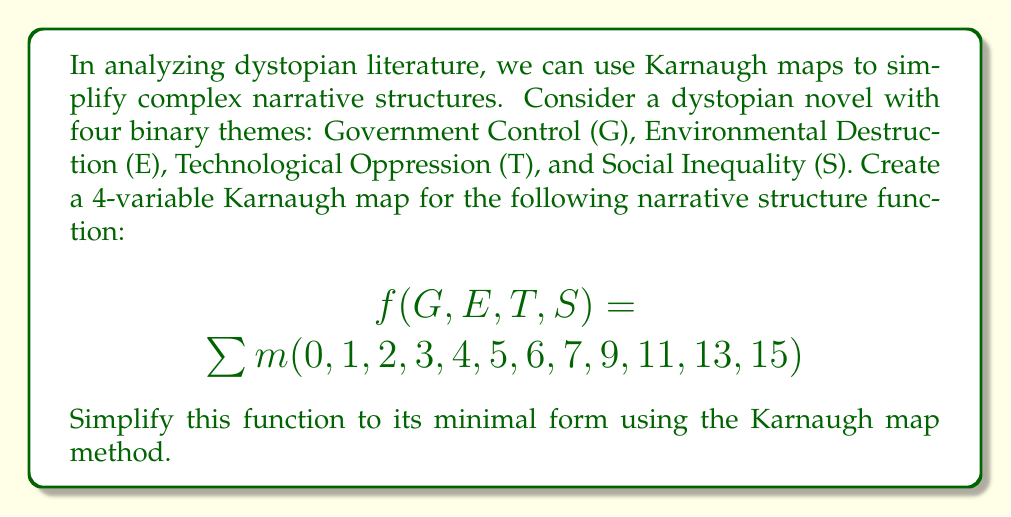Give your solution to this math problem. 1. First, we create a 4-variable Karnaugh map:

[asy]
unitsize(1cm);
for(int i=0; i<4; ++i) {
  for(int j=0; j<4; ++j) {
    draw((i,j)--(i+1,j)--(i+1,j+1)--(i,j+1)--cycle);
  }
}
label("00", (0.5,-0.5));
label("01", (1.5,-0.5));
label("11", (2.5,-0.5));
label("10", (3.5,-0.5));
label("00", (-0.5,0.5));
label("01", (-0.5,1.5));
label("11", (-0.5,2.5));
label("10", (-0.5,3.5));
label("GE", (-0.5,-0.5));
label("TS", (4.5,3.5));
[/asy]

2. Fill in the Karnaugh map with 1's for the given minterms:

[asy]
unitsize(1cm);
for(int i=0; i<4; ++i) {
  for(int j=0; j<4; ++j) {
    draw((i,j)--(i+1,j)--(i+1,j+1)--(i,j+1)--cycle);
  }
}
label("1", (0.5,0.5));
label("1", (1.5,0.5));
label("1", (2.5,0.5));
label("1", (3.5,0.5));
label("1", (0.5,1.5));
label("1", (1.5,1.5));
label("1", (2.5,1.5));
label("1", (3.5,1.5));
label("1", (1.5,2.5));
label("1", (3.5,2.5));
label("1", (1.5,3.5));
label("1", (3.5,3.5));
label("00", (0.5,-0.5));
label("01", (1.5,-0.5));
label("11", (2.5,-0.5));
label("10", (3.5,-0.5));
label("00", (-0.5,0.5));
label("01", (-0.5,1.5));
label("11", (-0.5,2.5));
label("10", (-0.5,3.5));
label("GE", (-0.5,-0.5));
label("TS", (4.5,3.5));
[/asy]

3. Identify the largest possible groups of 1's:
   - Group of 8: covers the entire bottom half of the map ($$\overline{T}$$)
   - Group of 4: covers the right column ($$E$$)
   - Group of 2: covers the top-right corner ($$TS$$)

4. Write the simplified Boolean expression:
   $$f(G,E,T,S) = \overline{T} + E + TS$$

5. This expression represents the minimal form of the narrative structure function, where each term corresponds to a significant theme or combination of themes in the dystopian novel.
Answer: $$f(G,E,T,S) = \overline{T} + E + TS$$ 